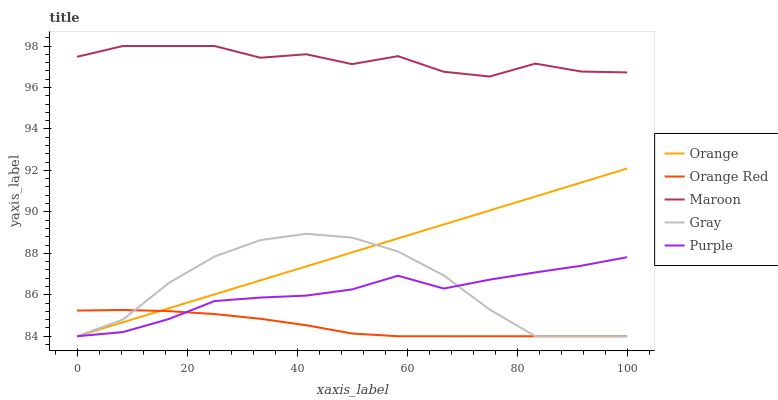Does Orange Red have the minimum area under the curve?
Answer yes or no. Yes. Does Maroon have the maximum area under the curve?
Answer yes or no. Yes. Does Gray have the minimum area under the curve?
Answer yes or no. No. Does Gray have the maximum area under the curve?
Answer yes or no. No. Is Orange the smoothest?
Answer yes or no. Yes. Is Maroon the roughest?
Answer yes or no. Yes. Is Gray the smoothest?
Answer yes or no. No. Is Gray the roughest?
Answer yes or no. No. Does Orange have the lowest value?
Answer yes or no. Yes. Does Maroon have the lowest value?
Answer yes or no. No. Does Maroon have the highest value?
Answer yes or no. Yes. Does Gray have the highest value?
Answer yes or no. No. Is Gray less than Maroon?
Answer yes or no. Yes. Is Maroon greater than Orange?
Answer yes or no. Yes. Does Orange Red intersect Gray?
Answer yes or no. Yes. Is Orange Red less than Gray?
Answer yes or no. No. Is Orange Red greater than Gray?
Answer yes or no. No. Does Gray intersect Maroon?
Answer yes or no. No. 